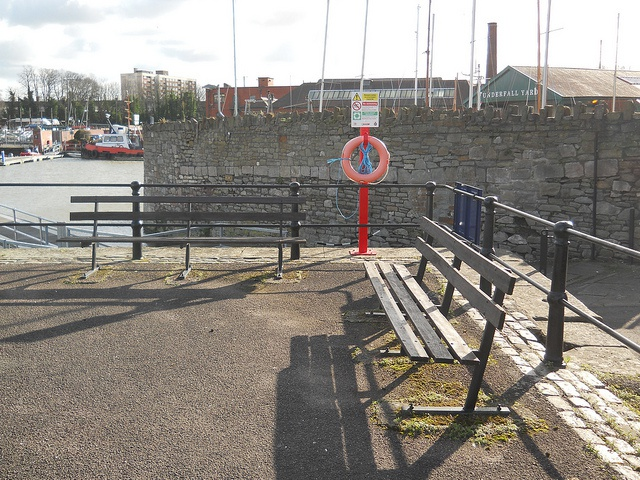Describe the objects in this image and their specific colors. I can see bench in lightgray, gray, black, and darkgray tones, bench in lightgray, gray, black, ivory, and darkgray tones, and boat in lightgray, gray, darkgray, and brown tones in this image. 